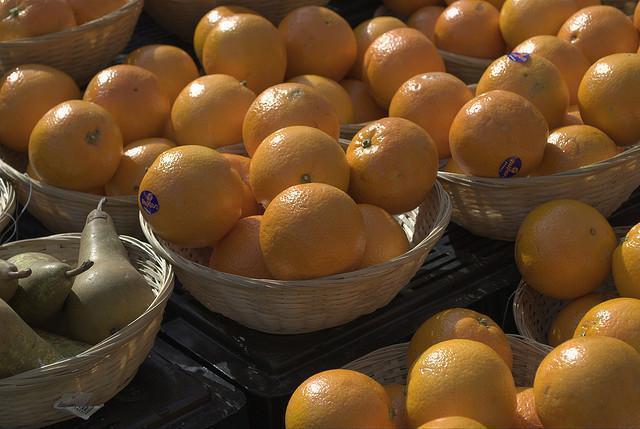What are the tan baskets made out of?
Pick the right solution, then justify: 'Answer: answer
Rationale: rationale.'
Options: Plastic, cotton, straw, aluminum. Answer: straw.
Rationale: They are made from straw 